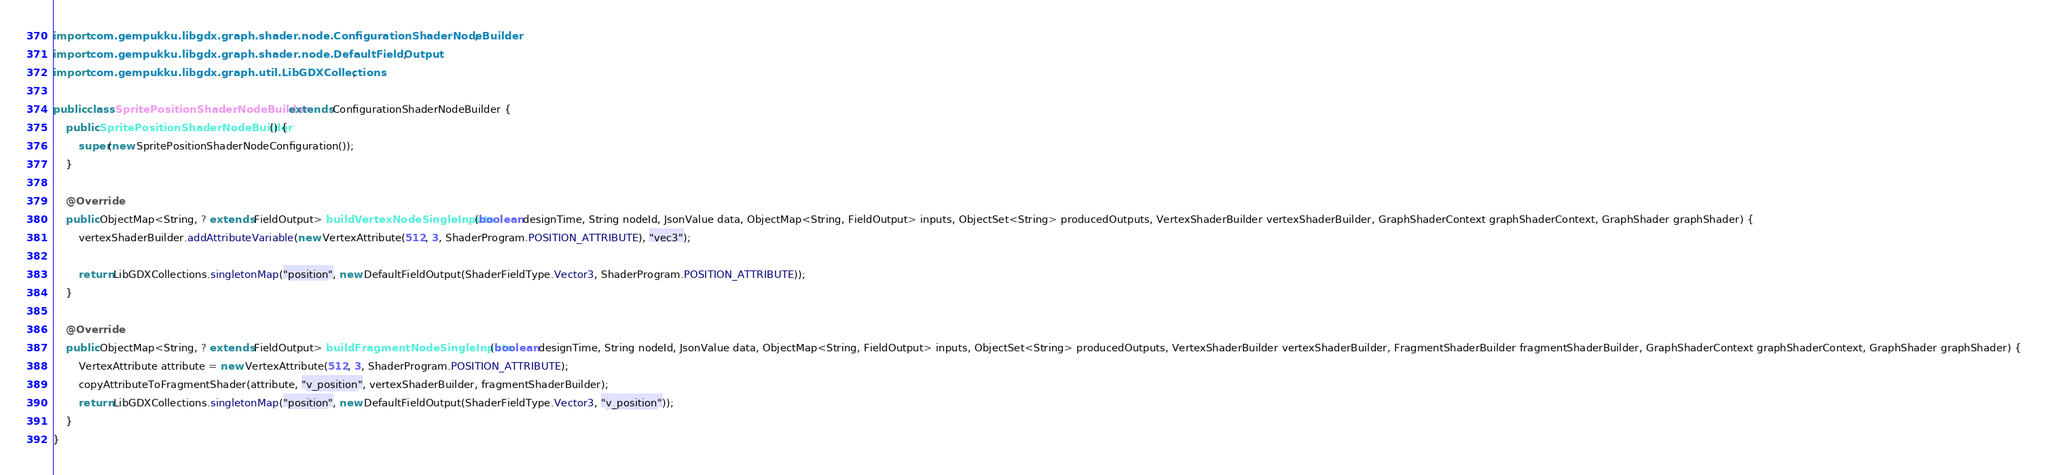Convert code to text. <code><loc_0><loc_0><loc_500><loc_500><_Java_>import com.gempukku.libgdx.graph.shader.node.ConfigurationShaderNodeBuilder;
import com.gempukku.libgdx.graph.shader.node.DefaultFieldOutput;
import com.gempukku.libgdx.graph.util.LibGDXCollections;

public class SpritePositionShaderNodeBuilder extends ConfigurationShaderNodeBuilder {
    public SpritePositionShaderNodeBuilder() {
        super(new SpritePositionShaderNodeConfiguration());
    }

    @Override
    public ObjectMap<String, ? extends FieldOutput> buildVertexNodeSingleInputs(boolean designTime, String nodeId, JsonValue data, ObjectMap<String, FieldOutput> inputs, ObjectSet<String> producedOutputs, VertexShaderBuilder vertexShaderBuilder, GraphShaderContext graphShaderContext, GraphShader graphShader) {
        vertexShaderBuilder.addAttributeVariable(new VertexAttribute(512, 3, ShaderProgram.POSITION_ATTRIBUTE), "vec3");

        return LibGDXCollections.singletonMap("position", new DefaultFieldOutput(ShaderFieldType.Vector3, ShaderProgram.POSITION_ATTRIBUTE));
    }

    @Override
    public ObjectMap<String, ? extends FieldOutput> buildFragmentNodeSingleInputs(boolean designTime, String nodeId, JsonValue data, ObjectMap<String, FieldOutput> inputs, ObjectSet<String> producedOutputs, VertexShaderBuilder vertexShaderBuilder, FragmentShaderBuilder fragmentShaderBuilder, GraphShaderContext graphShaderContext, GraphShader graphShader) {
        VertexAttribute attribute = new VertexAttribute(512, 3, ShaderProgram.POSITION_ATTRIBUTE);
        copyAttributeToFragmentShader(attribute, "v_position", vertexShaderBuilder, fragmentShaderBuilder);
        return LibGDXCollections.singletonMap("position", new DefaultFieldOutput(ShaderFieldType.Vector3, "v_position"));
    }
}
</code> 